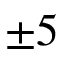<formula> <loc_0><loc_0><loc_500><loc_500>\pm 5</formula> 